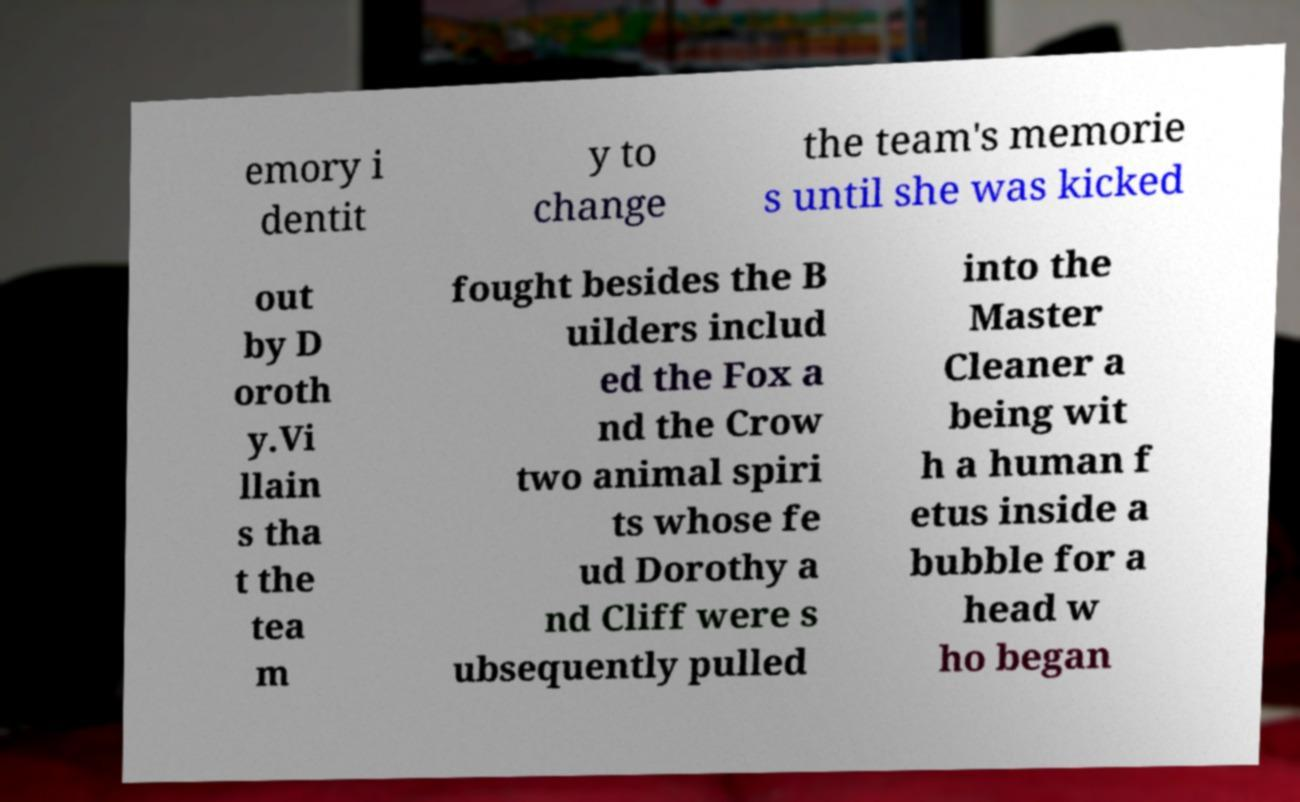Could you extract and type out the text from this image? emory i dentit y to change the team's memorie s until she was kicked out by D oroth y.Vi llain s tha t the tea m fought besides the B uilders includ ed the Fox a nd the Crow two animal spiri ts whose fe ud Dorothy a nd Cliff were s ubsequently pulled into the Master Cleaner a being wit h a human f etus inside a bubble for a head w ho began 